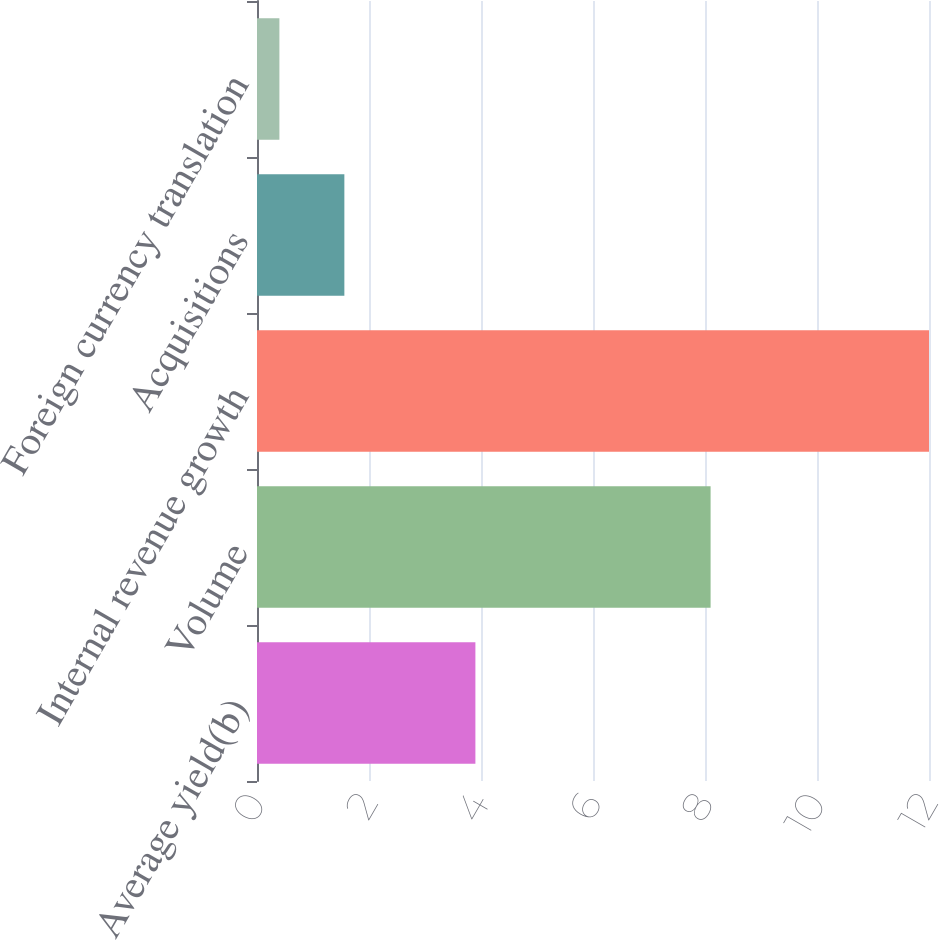Convert chart to OTSL. <chart><loc_0><loc_0><loc_500><loc_500><bar_chart><fcel>Average yield(b)<fcel>Volume<fcel>Internal revenue growth<fcel>Acquisitions<fcel>Foreign currency translation<nl><fcel>3.9<fcel>8.1<fcel>12<fcel>1.56<fcel>0.4<nl></chart> 